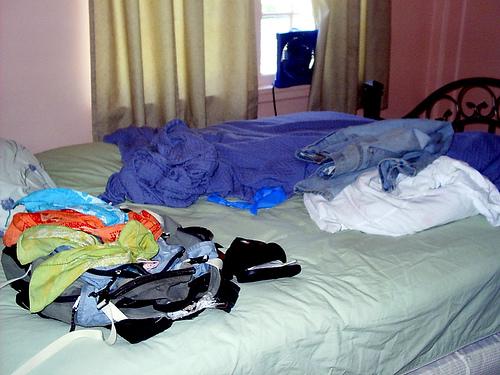Could this sheet use some ironing?
Give a very brief answer. Yes. What color is the sheet?
Quick response, please. Green. What are all the clothes sitting on?
Short answer required. Bed. 